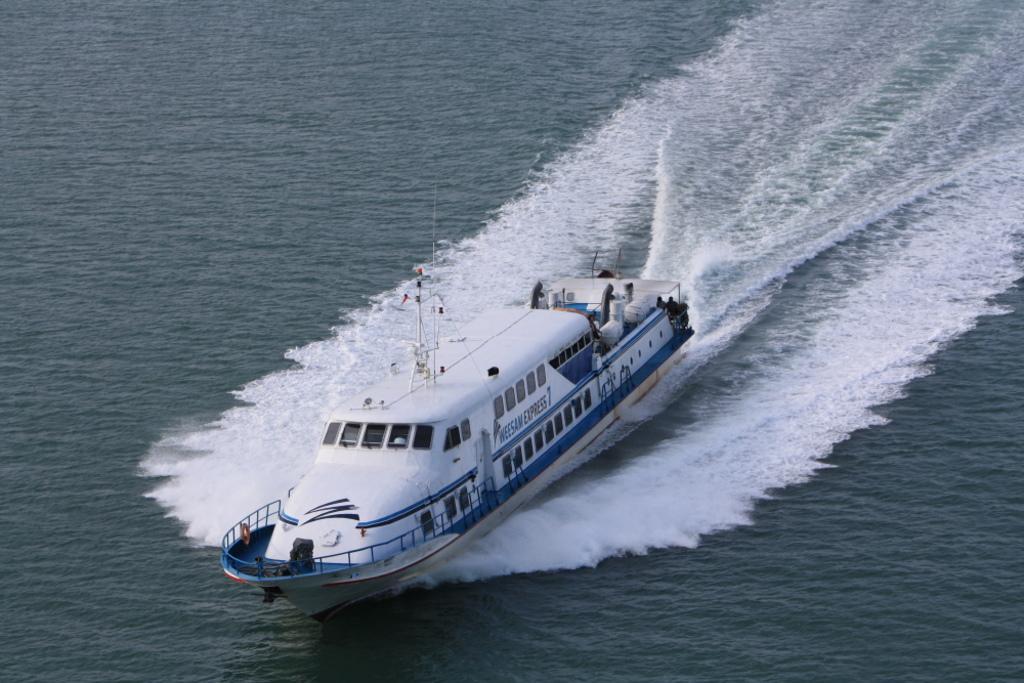Could you give a brief overview of what you see in this image? In the middle of this image I can see a ship on the water. 